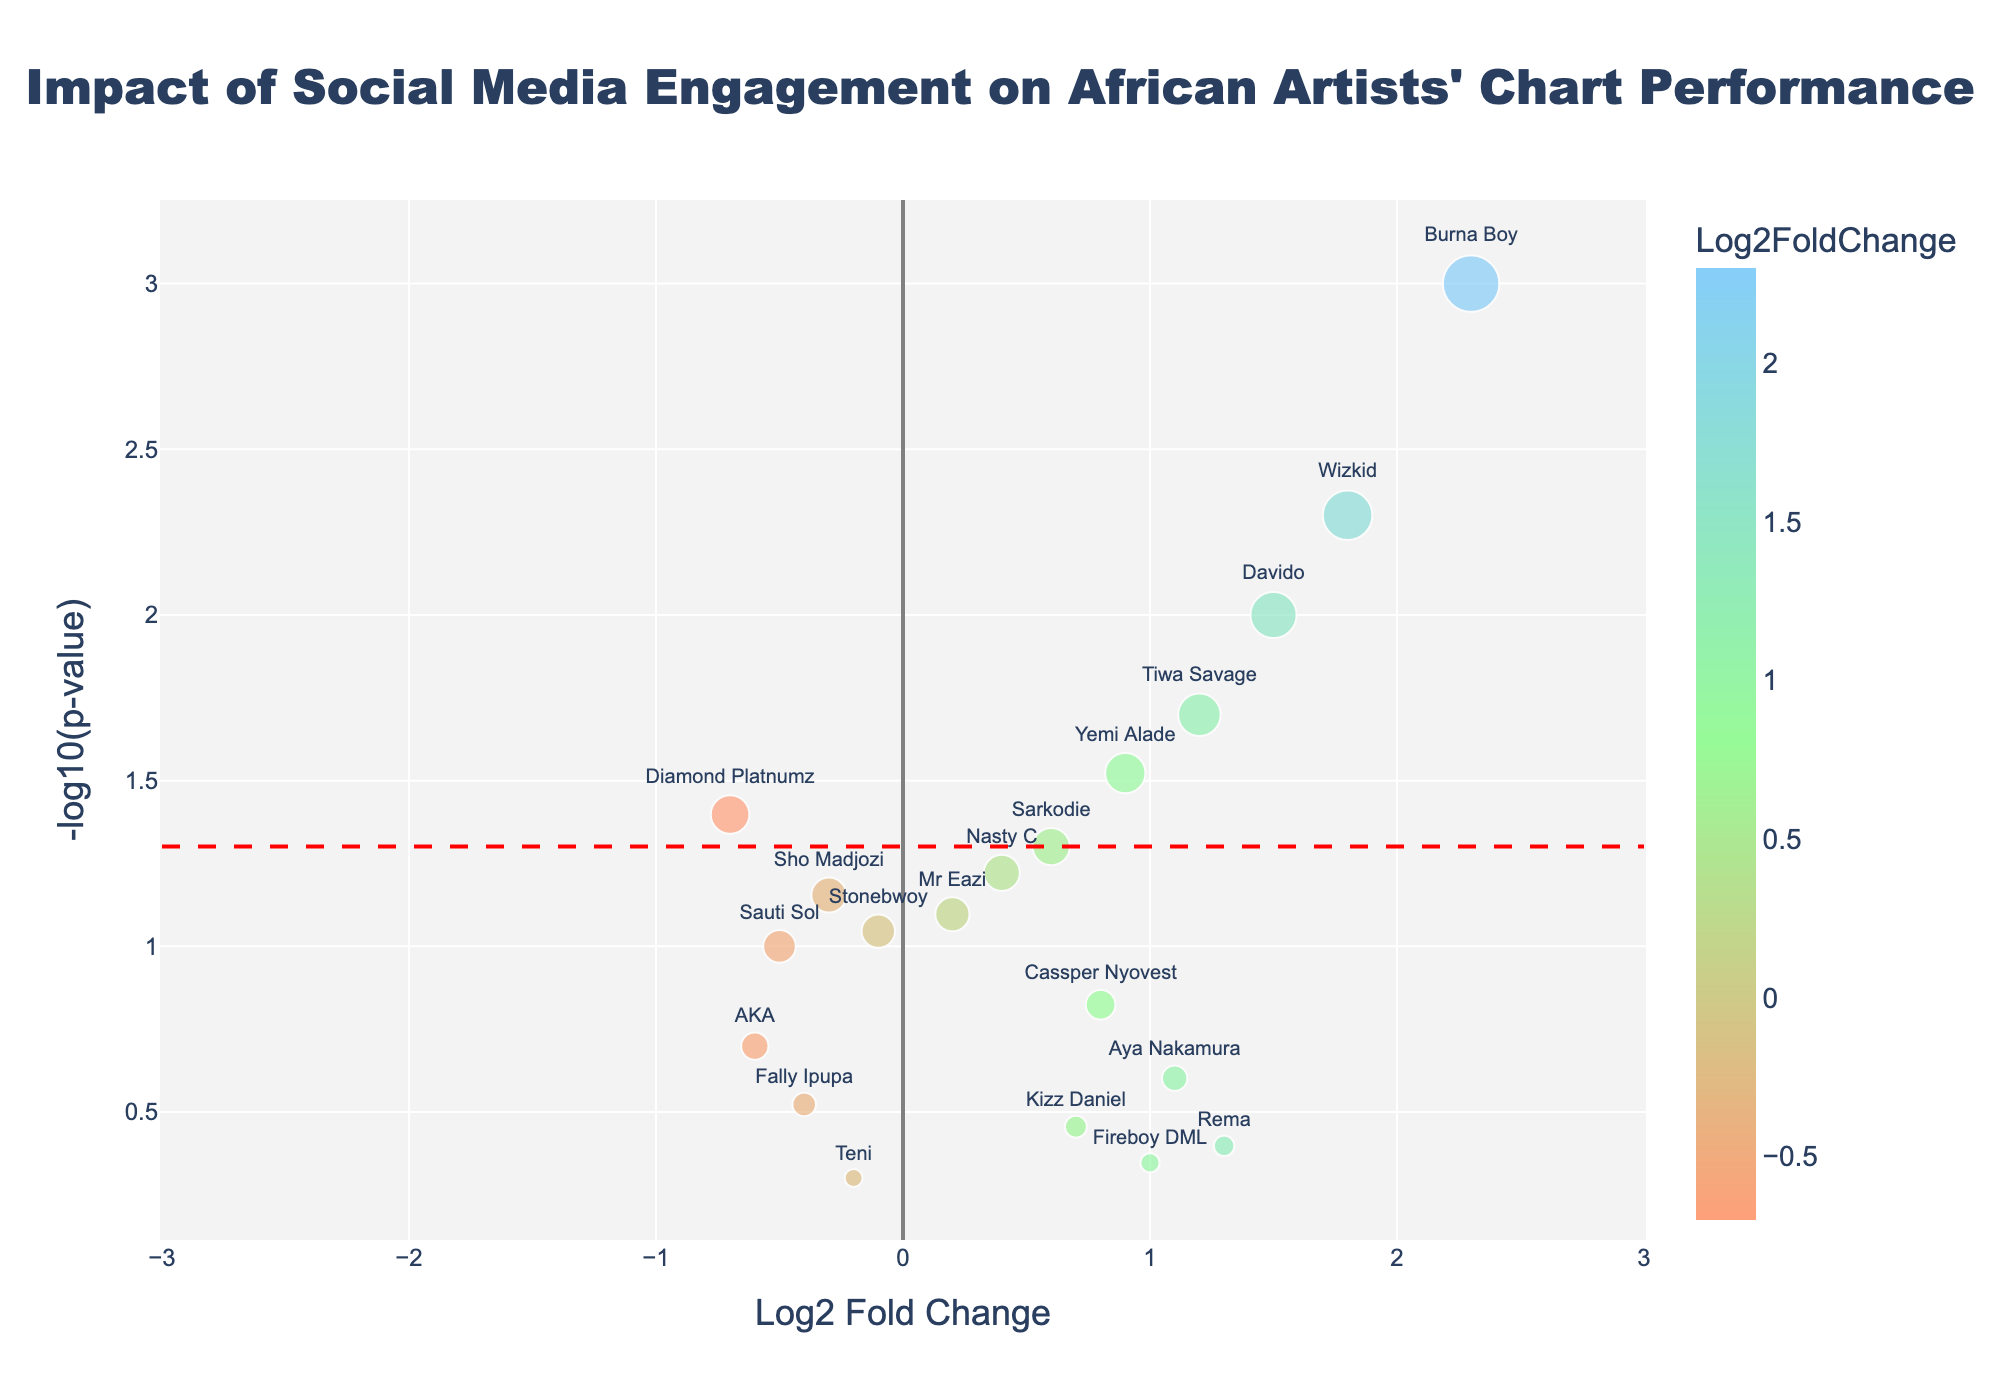What is the title of the chart? The title of the chart is clearly displayed at the top center. It reads, "Impact of Social Media Engagement on African Artists' Chart Performance."
Answer: Impact of Social Media Engagement on African Artists' Chart Performance Which artist has the highest -log10(p-value)? To determine this, look for the data point that is highest on the y-axis. The highest point on the y-axis corresponds to Burna Boy.
Answer: Burna Boy How many artists have a positive Log2FoldChange value? To find this, count all data points to the right of the y-axis (positive Log2FoldChange values). The artists with positive values are Burna Boy, Wizkid, Davido, Tiwa Savage, Yemi Alade, Sarkodie, Nasty C, Mr Eazi, Cassper Nyovest, Aya Nakamura, Kizz Daniel, and Rema.
Answer: 12 Which artist has the smallest Log2FoldChange value? Identify the point furthest to the left on the x-axis. The artist with the smallest Log2FoldChange value is Diamond Platnumz.
Answer: Diamond Platnumz What is the significance threshold line and what is its y-axis value? The significance threshold line can be observed as a dashed red line. It corresponds to a y value of -log10(0.05), which is approximately 1.30.
Answer: ~1.30 Which artists fall below the threshold significance line? Identify artists whose data points fall below the red dashed line on the y-axis. These artists are Nasty C, Sho Madjozi, Mr Eazi, Stonebwoy, Sauti Sol, Cassper Nyovest, AKA, Aya Nakamura, Fally Ipupa, Kizz Daniel, Rema, Fireboy DML, and Teni.
Answer: 13 artists Compare Burna Boy and Wizkid in terms of Log2FoldChange and -log10(p-value)? Who has a higher value for each metric? For Log2FoldChange, compare their x-axis positions. Burna Boy has a higher Log2FoldChange (2.3) than Wizkid (1.8). For -log10(p-value), compare their y-axis positions. Burna Boy also has a higher -log10(p-value) than Wizkid.
Answer: Burna Boy What is the Log2FoldChange and p-value for Tiwa Savage? Locate Tiwa Savage on the plot and check the corresponding x and y values. Tiwa Savage has a Log2FoldChange of 1.2 and a p-value of 0.02. The -log10(p-value) can be calculated as -log10(0.02), which is approximately 1.70.
Answer: Log2FoldChange: 1.2, p-value: 0.02 How do the fold changes for the singers with the highest and lowest -log10(p-value) compare? The singer with the highest -log10(p-value) is Burna Boy with a Log2FoldChange of 2.3. The one with the lowest -log10(p-value) is Teni with a Log2FoldChange of -0.2. The difference between their Log2FoldChanges is 2.3 - (-0.2) = 2.5.
Answer: Difference: 2.5 Which artists have a -log10(p-value) greater than 1.5 and what are their Log2FoldChanges? To find this, identify artists with data points above 1.5 on the y-axis. These artists are Burna Boy with a Log2FoldChange of 2.3, Wizkid with a Log2FoldChange of 1.8, Davido with a Log2FoldChange of 1.5, and Tiwa Savage with a Log2FoldChange of 1.2.
Answer: Burna Boy: 2.3, Wizkid: 1.8, Davido: 1.5, Tiwa Savage: 1.2 